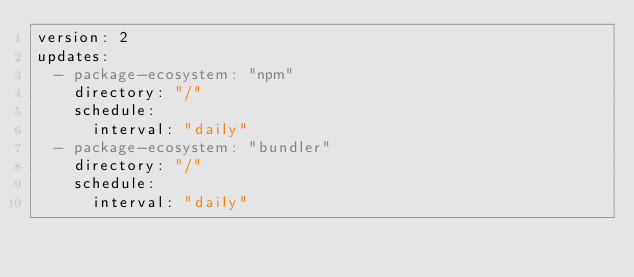<code> <loc_0><loc_0><loc_500><loc_500><_YAML_>version: 2
updates:
  - package-ecosystem: "npm"
    directory: "/"
    schedule:
      interval: "daily"
  - package-ecosystem: "bundler"
    directory: "/"
    schedule:
      interval: "daily"
</code> 